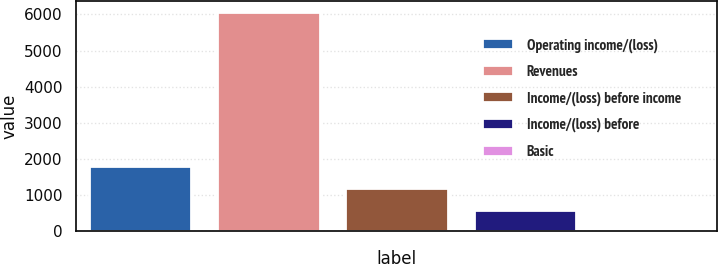Convert chart to OTSL. <chart><loc_0><loc_0><loc_500><loc_500><bar_chart><fcel>Operating income/(loss)<fcel>Revenues<fcel>Income/(loss) before income<fcel>Income/(loss) before<fcel>Basic<nl><fcel>1817.73<fcel>6059<fcel>1211.84<fcel>605.95<fcel>0.06<nl></chart> 